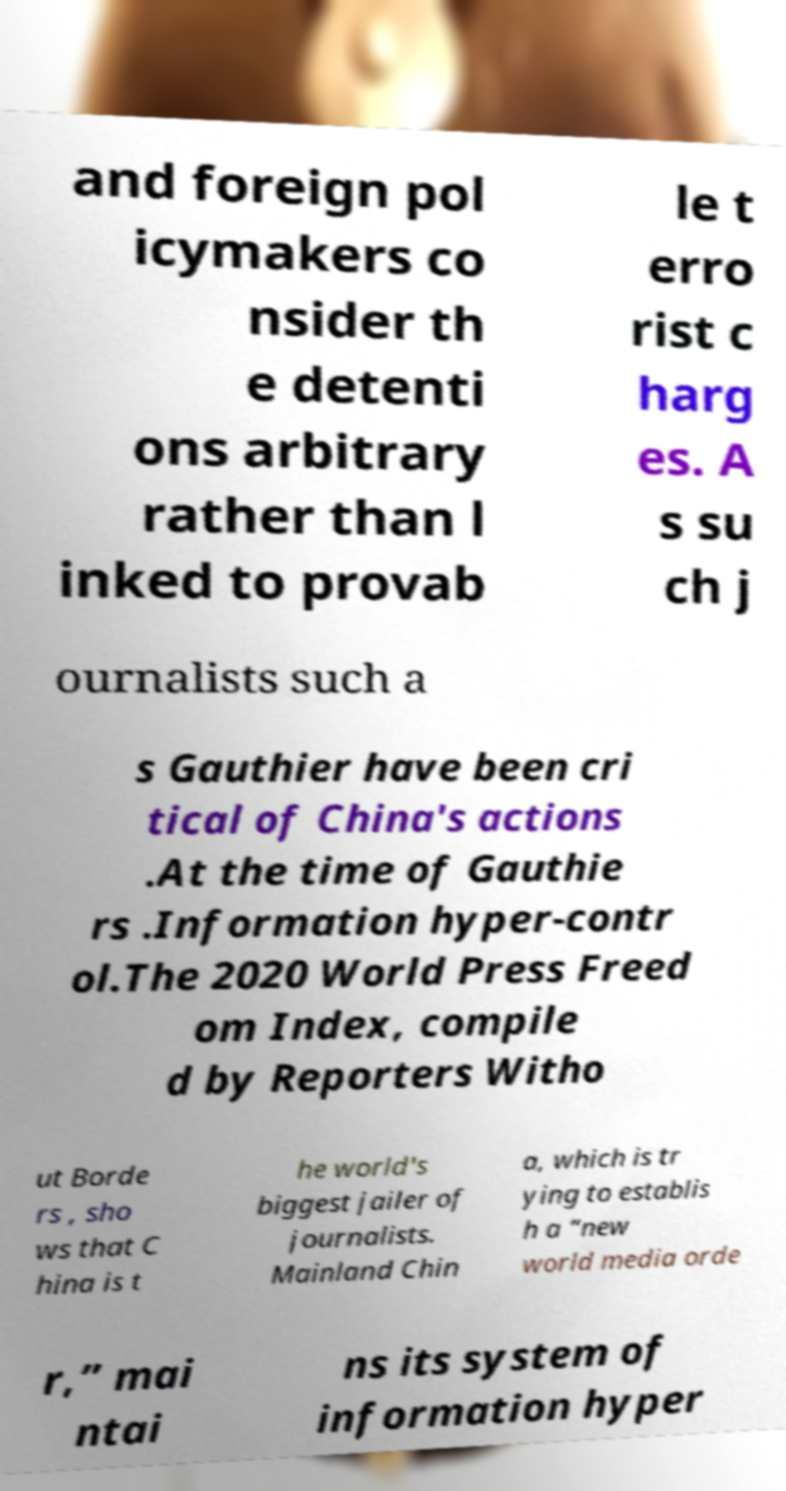For documentation purposes, I need the text within this image transcribed. Could you provide that? and foreign pol icymakers co nsider th e detenti ons arbitrary rather than l inked to provab le t erro rist c harg es. A s su ch j ournalists such a s Gauthier have been cri tical of China's actions .At the time of Gauthie rs .Information hyper-contr ol.The 2020 World Press Freed om Index, compile d by Reporters Witho ut Borde rs , sho ws that C hina is t he world's biggest jailer of journalists. Mainland Chin a, which is tr ying to establis h a “new world media orde r,” mai ntai ns its system of information hyper 